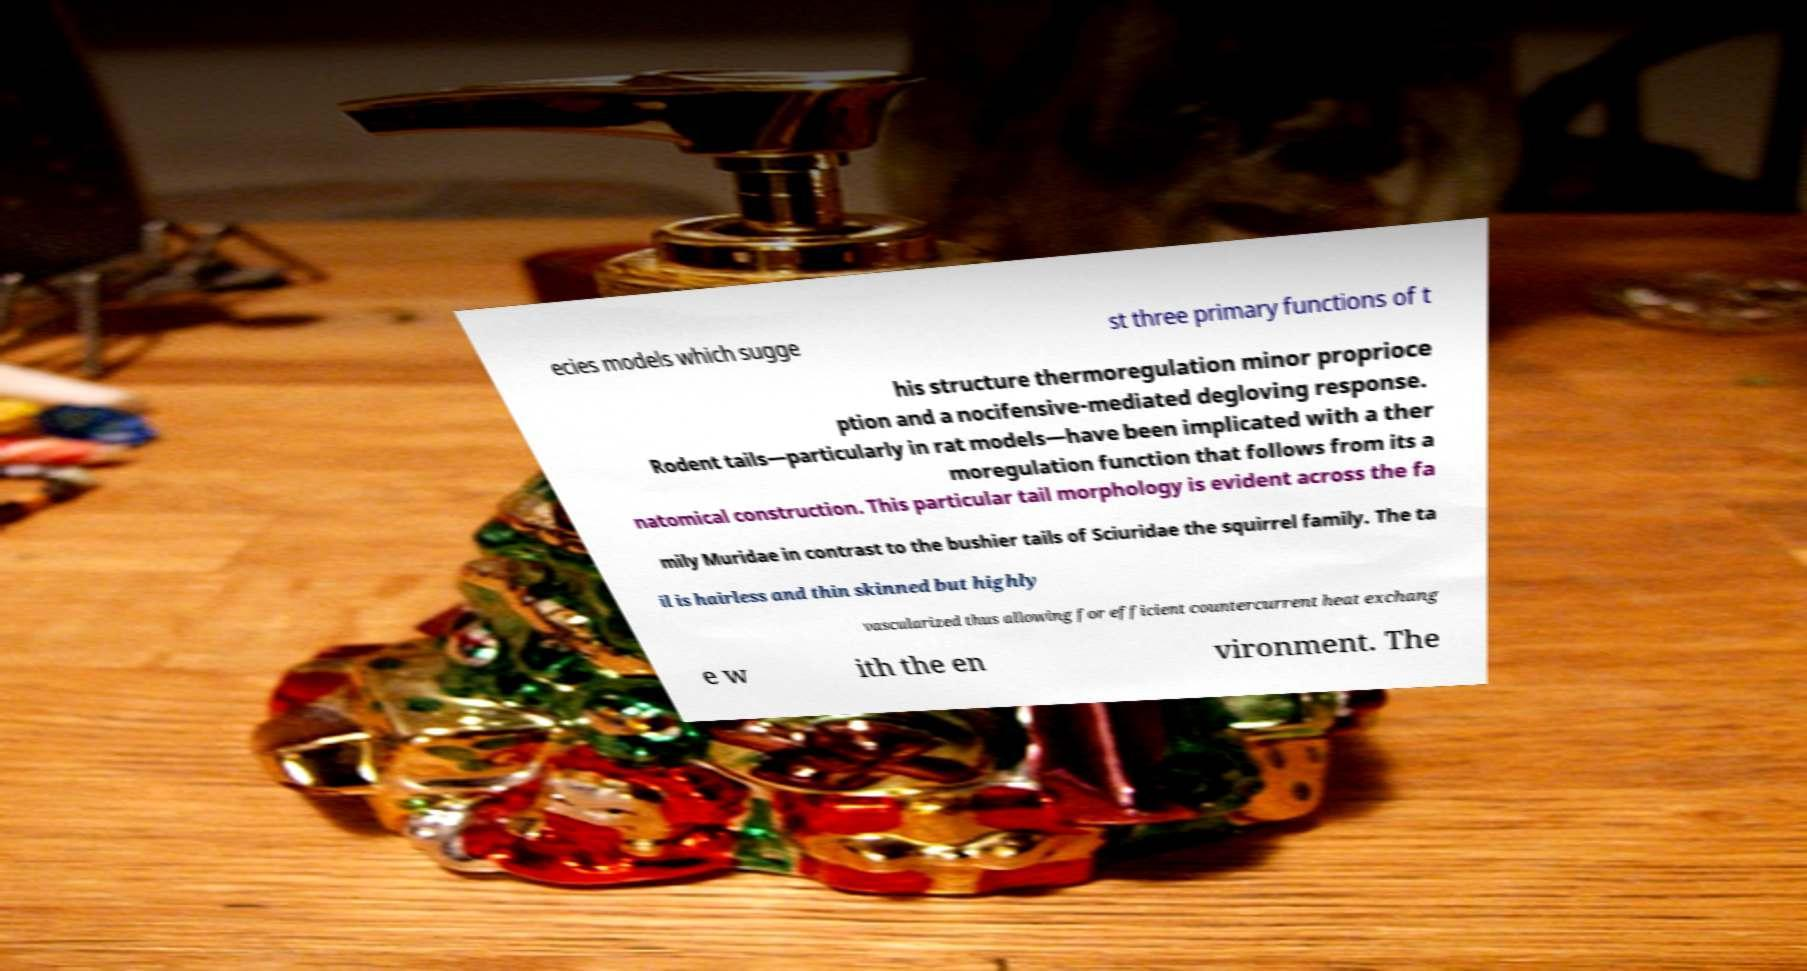Could you assist in decoding the text presented in this image and type it out clearly? ecies models which sugge st three primary functions of t his structure thermoregulation minor proprioce ption and a nocifensive-mediated degloving response. Rodent tails—particularly in rat models—have been implicated with a ther moregulation function that follows from its a natomical construction. This particular tail morphology is evident across the fa mily Muridae in contrast to the bushier tails of Sciuridae the squirrel family. The ta il is hairless and thin skinned but highly vascularized thus allowing for efficient countercurrent heat exchang e w ith the en vironment. The 